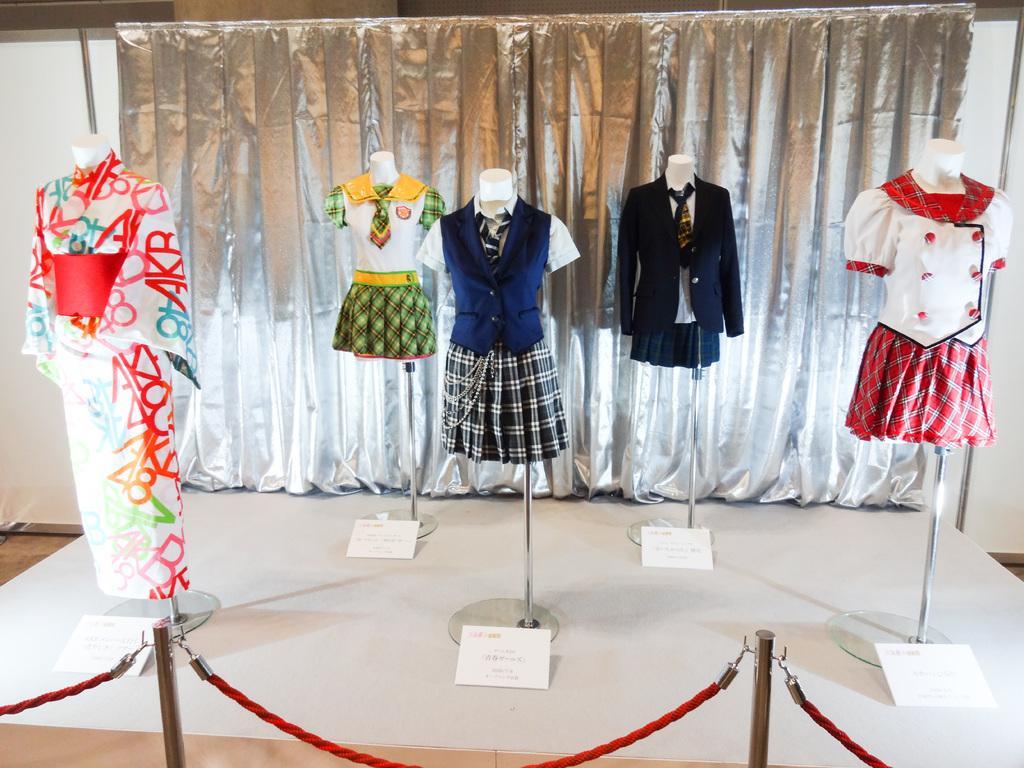Describe this image in one or two sentences. In the background we can see the silver cloth. In this picture we can see the mannequins, stands, clothes, white boards with some information. At the bottom portion of the picture we can see the pole rope barrier. 